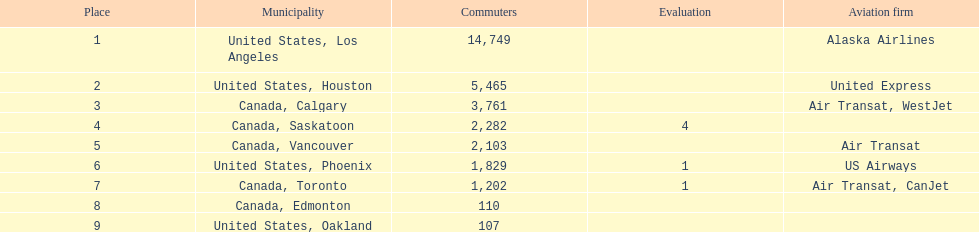What numbers are in the passengers column? 14,749, 5,465, 3,761, 2,282, 2,103, 1,829, 1,202, 110, 107. Which number is the lowest number in the passengers column? 107. What city is associated with this number? United States, Oakland. 